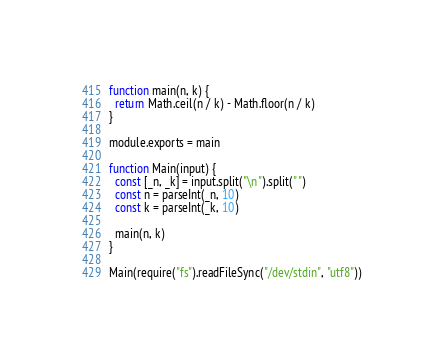<code> <loc_0><loc_0><loc_500><loc_500><_JavaScript_>function main(n, k) {
  return Math.ceil(n / k) - Math.floor(n / k)
}

module.exports = main

function Main(input) {
  const [_n, _k] = input.split("\n").split(" ")
  const n = parseInt(_n, 10)
  const k = parseInt(_k, 10)

  main(n, k)
}

Main(require("fs").readFileSync("/dev/stdin", "utf8"))</code> 